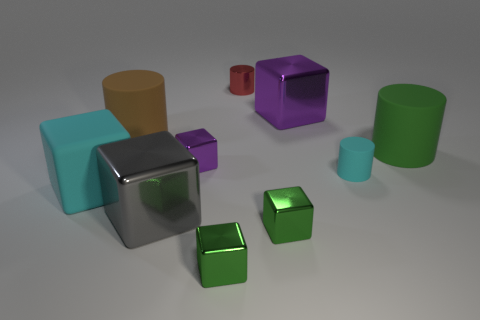How many objects are large things that are behind the big cyan matte cube or red shiny cylinders?
Provide a short and direct response. 4. How many objects are either big objects or large shiny things that are in front of the big green matte object?
Give a very brief answer. 5. There is a green thing that is behind the big shiny object in front of the small cyan object; what number of red metal objects are left of it?
Your answer should be very brief. 1. What is the material of the cyan object that is the same size as the gray object?
Keep it short and to the point. Rubber. Are there any other green cylinders of the same size as the green cylinder?
Your answer should be compact. No. The metallic cylinder is what color?
Give a very brief answer. Red. What is the color of the rubber thing that is in front of the cyan rubber object on the right side of the gray shiny object?
Offer a very short reply. Cyan. There is a cyan thing that is left of the shiny cube behind the purple metallic object left of the metallic cylinder; what is its shape?
Offer a terse response. Cube. What number of large gray blocks have the same material as the small purple object?
Provide a short and direct response. 1. There is a cyan rubber thing that is behind the cyan rubber cube; how many objects are to the right of it?
Make the answer very short. 1. 